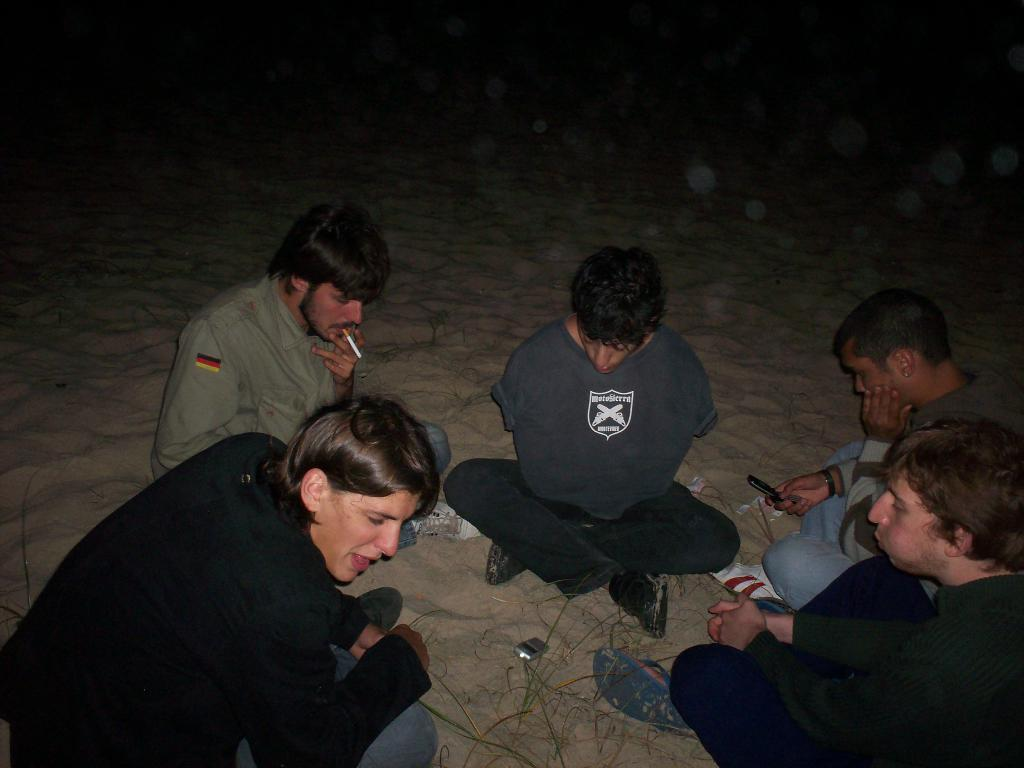What is the surface that the people are sitting on in the image? The people are sitting on a sand surface in the image. What is one man doing in the image? One man is smoking in the image. What activity is one person engaged in? One person is operating a mobile phone in the image. What is the limit of the mark on the sand in the image? There is no mention of a mark on the sand in the image, so it is not possible to determine a limit. 